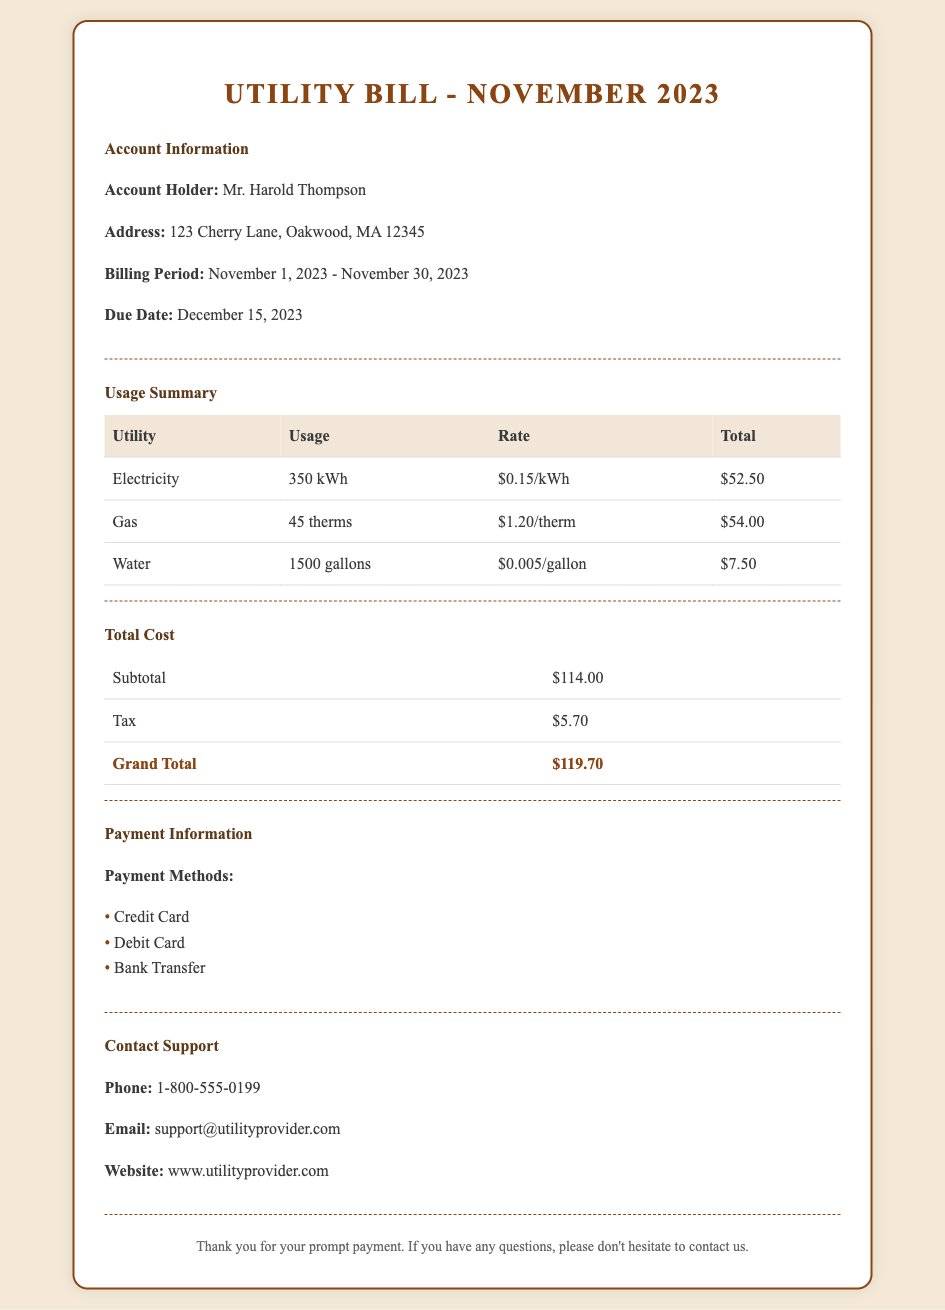What is the billing period? The billing period is the time frame for which the bill is calculated, which is from November 1, 2023 to November 30, 2023.
Answer: November 1, 2023 - November 30, 2023 How much is the total cost? The total cost is shown as the grand total in the document, which includes the subtotal and tax.
Answer: $119.70 What is the account holder's name? The account holder is the individual responsible for the utility account, which is provided in the account information section.
Answer: Mr. Harold Thompson What is the rate for electricity usage? The rate for electricity is specified in the usage summary table alongside the electricity usage.
Answer: $0.15/kWh What is the due date for payment? The due date indicates when the payment must be made to avoid penalties, noted in the account information section.
Answer: December 15, 2023 What is the usage for gas? The usage for gas indicates how much gas was used during the billing period, found in the usage summary table.
Answer: 45 therms What is the subtotal before tax? The subtotal is the amount before adding any taxes, which is listed in the total cost section of the document.
Answer: $114.00 Which payment method is NOT listed? This question checks if a payment method is absent from the list provided under payment information.
Answer: Cash What is the contact phone number for support? The contact phone number is provided for customers to reach out for assistance, mentioned in the contact support section.
Answer: 1-800-555-0199 